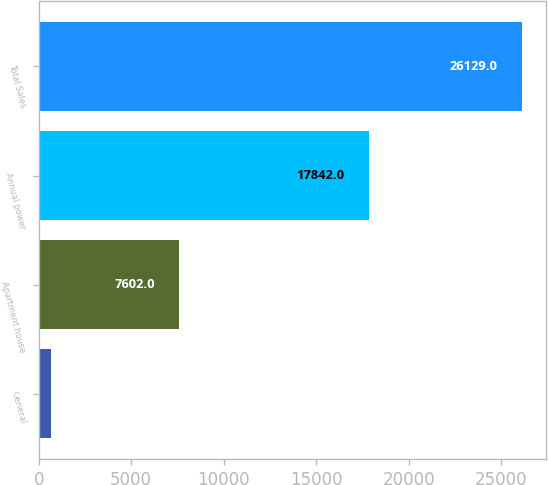Convert chart. <chart><loc_0><loc_0><loc_500><loc_500><bar_chart><fcel>General<fcel>Apartment house<fcel>Annual power<fcel>Total Sales<nl><fcel>685<fcel>7602<fcel>17842<fcel>26129<nl></chart> 